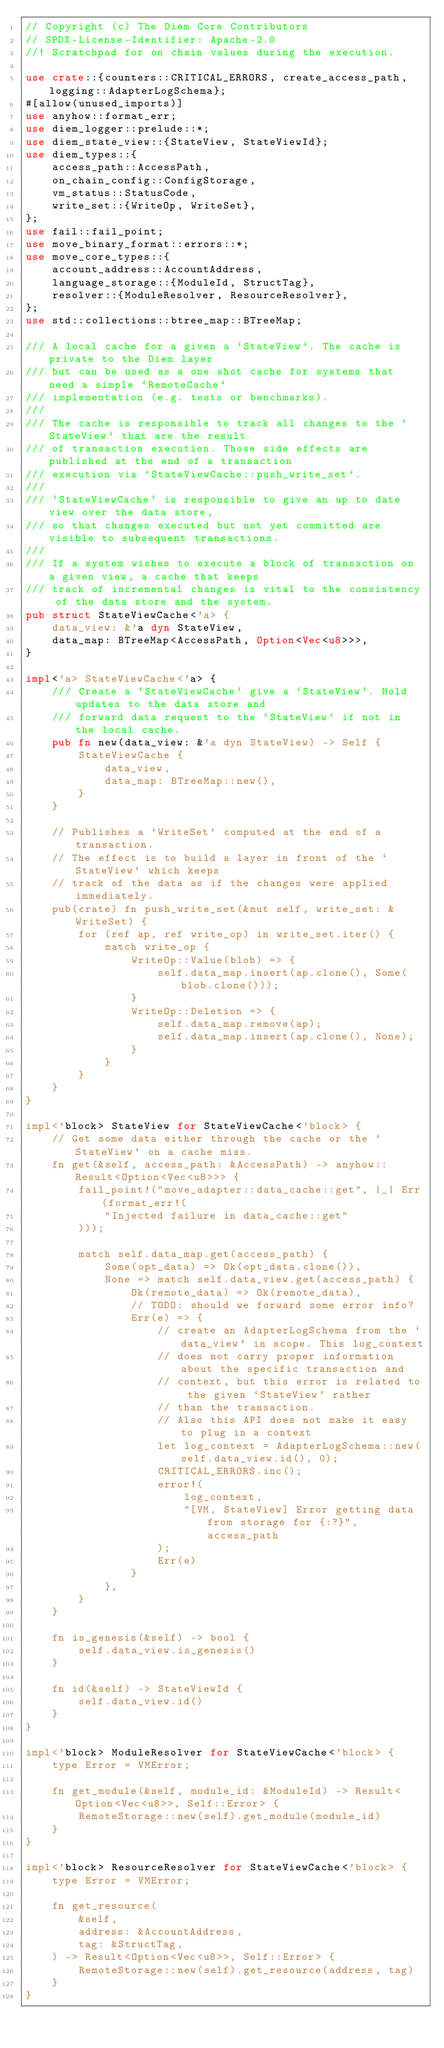Convert code to text. <code><loc_0><loc_0><loc_500><loc_500><_Rust_>// Copyright (c) The Diem Core Contributors
// SPDX-License-Identifier: Apache-2.0
//! Scratchpad for on chain values during the execution.

use crate::{counters::CRITICAL_ERRORS, create_access_path, logging::AdapterLogSchema};
#[allow(unused_imports)]
use anyhow::format_err;
use diem_logger::prelude::*;
use diem_state_view::{StateView, StateViewId};
use diem_types::{
    access_path::AccessPath,
    on_chain_config::ConfigStorage,
    vm_status::StatusCode,
    write_set::{WriteOp, WriteSet},
};
use fail::fail_point;
use move_binary_format::errors::*;
use move_core_types::{
    account_address::AccountAddress,
    language_storage::{ModuleId, StructTag},
    resolver::{ModuleResolver, ResourceResolver},
};
use std::collections::btree_map::BTreeMap;

/// A local cache for a given a `StateView`. The cache is private to the Diem layer
/// but can be used as a one shot cache for systems that need a simple `RemoteCache`
/// implementation (e.g. tests or benchmarks).
///
/// The cache is responsible to track all changes to the `StateView` that are the result
/// of transaction execution. Those side effects are published at the end of a transaction
/// execution via `StateViewCache::push_write_set`.
///
/// `StateViewCache` is responsible to give an up to date view over the data store,
/// so that changes executed but not yet committed are visible to subsequent transactions.
///
/// If a system wishes to execute a block of transaction on a given view, a cache that keeps
/// track of incremental changes is vital to the consistency of the data store and the system.
pub struct StateViewCache<'a> {
    data_view: &'a dyn StateView,
    data_map: BTreeMap<AccessPath, Option<Vec<u8>>>,
}

impl<'a> StateViewCache<'a> {
    /// Create a `StateViewCache` give a `StateView`. Hold updates to the data store and
    /// forward data request to the `StateView` if not in the local cache.
    pub fn new(data_view: &'a dyn StateView) -> Self {
        StateViewCache {
            data_view,
            data_map: BTreeMap::new(),
        }
    }

    // Publishes a `WriteSet` computed at the end of a transaction.
    // The effect is to build a layer in front of the `StateView` which keeps
    // track of the data as if the changes were applied immediately.
    pub(crate) fn push_write_set(&mut self, write_set: &WriteSet) {
        for (ref ap, ref write_op) in write_set.iter() {
            match write_op {
                WriteOp::Value(blob) => {
                    self.data_map.insert(ap.clone(), Some(blob.clone()));
                }
                WriteOp::Deletion => {
                    self.data_map.remove(ap);
                    self.data_map.insert(ap.clone(), None);
                }
            }
        }
    }
}

impl<'block> StateView for StateViewCache<'block> {
    // Get some data either through the cache or the `StateView` on a cache miss.
    fn get(&self, access_path: &AccessPath) -> anyhow::Result<Option<Vec<u8>>> {
        fail_point!("move_adapter::data_cache::get", |_| Err(format_err!(
            "Injected failure in data_cache::get"
        )));

        match self.data_map.get(access_path) {
            Some(opt_data) => Ok(opt_data.clone()),
            None => match self.data_view.get(access_path) {
                Ok(remote_data) => Ok(remote_data),
                // TODO: should we forward some error info?
                Err(e) => {
                    // create an AdapterLogSchema from the `data_view` in scope. This log_context
                    // does not carry proper information about the specific transaction and
                    // context, but this error is related to the given `StateView` rather
                    // than the transaction.
                    // Also this API does not make it easy to plug in a context
                    let log_context = AdapterLogSchema::new(self.data_view.id(), 0);
                    CRITICAL_ERRORS.inc();
                    error!(
                        log_context,
                        "[VM, StateView] Error getting data from storage for {:?}", access_path
                    );
                    Err(e)
                }
            },
        }
    }

    fn is_genesis(&self) -> bool {
        self.data_view.is_genesis()
    }

    fn id(&self) -> StateViewId {
        self.data_view.id()
    }
}

impl<'block> ModuleResolver for StateViewCache<'block> {
    type Error = VMError;

    fn get_module(&self, module_id: &ModuleId) -> Result<Option<Vec<u8>>, Self::Error> {
        RemoteStorage::new(self).get_module(module_id)
    }
}

impl<'block> ResourceResolver for StateViewCache<'block> {
    type Error = VMError;

    fn get_resource(
        &self,
        address: &AccountAddress,
        tag: &StructTag,
    ) -> Result<Option<Vec<u8>>, Self::Error> {
        RemoteStorage::new(self).get_resource(address, tag)
    }
}
</code> 